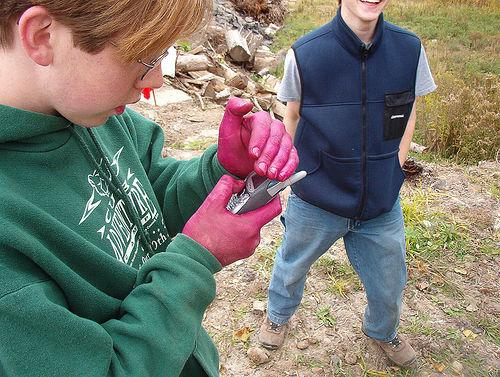Question: who has on a blue vest?
Choices:
A. Girl on left.
B. Man in back.
C. Boy on right.
D. Woman in front.
Answer with the letter. Answer: C Question: why is the horse running?
Choices:
A. It is frightened.
B. No horse.
C. It is hungry.
D. It is happy.
Answer with the letter. Answer: B Question: what has a green shirt?
Choices:
A. Girl on right.
B. Man in back.
C. Woman in front.
D. Boy on left.
Answer with the letter. Answer: D Question: what is the snake doing?
Choices:
A. Eating.
B. No snake.
C. Sleeping.
D. Crawling.
Answer with the letter. Answer: B Question: when is it daytime?
Choices:
A. Now.
B. Earlier.
C. Much later.
D. Much earlier.
Answer with the letter. Answer: A 